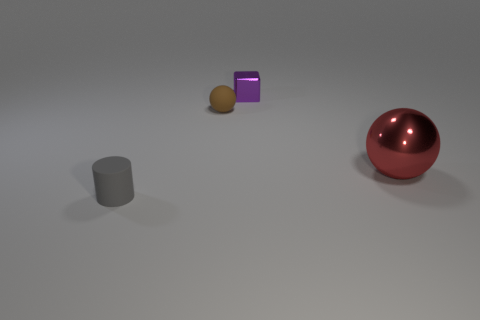How would you describe the lighting in this scene? The lighting in the scene is soft and diffused, suggesting an indoor setting possibly lit by overhead artificial lights, as evidenced by the gentle shadows under the objects. 